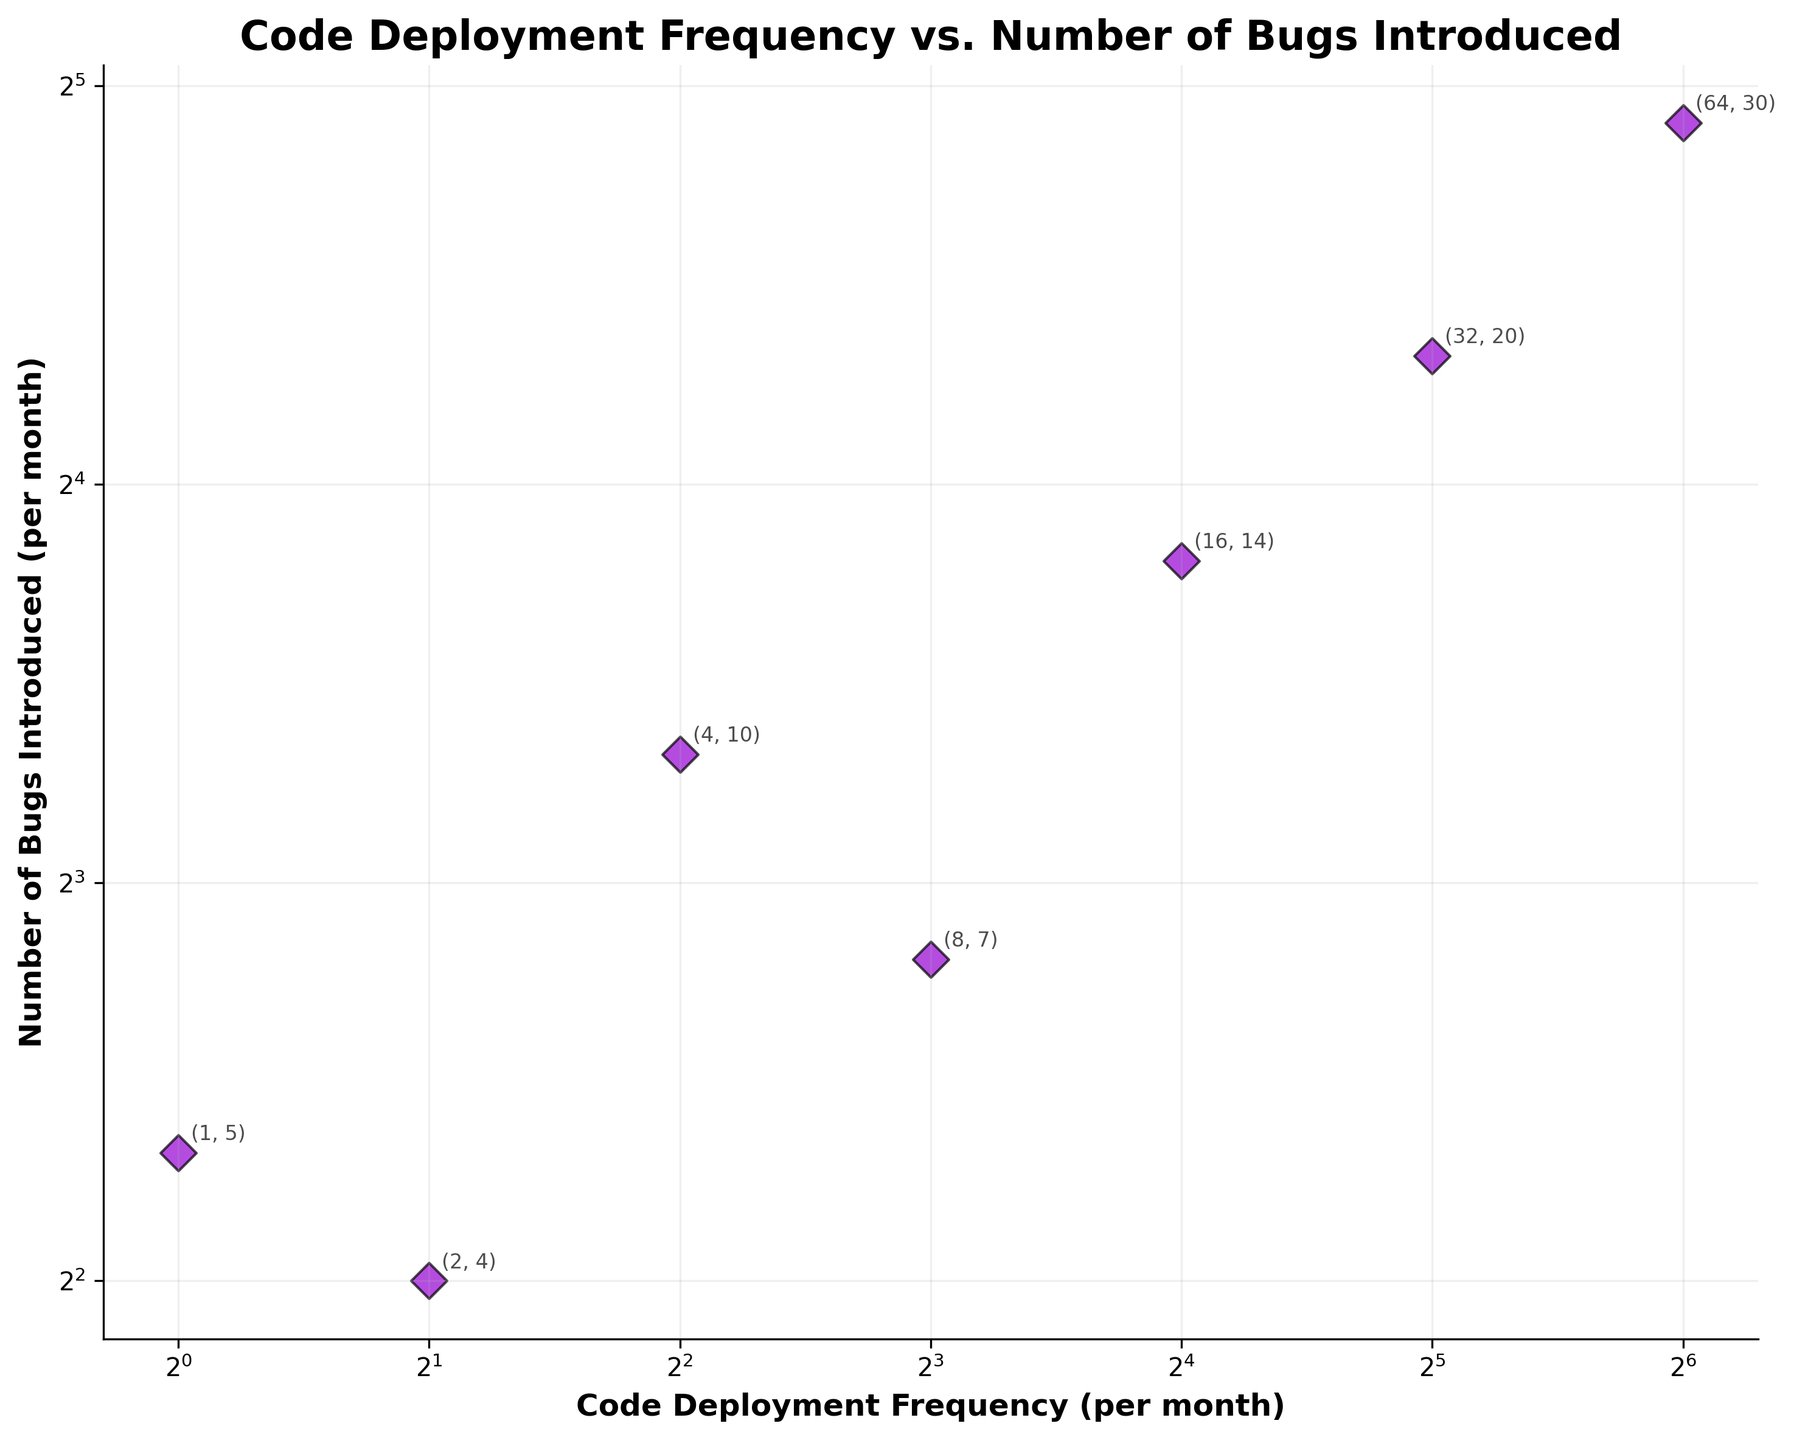What is the title of the scatter plot? The figure's title is displayed at the top and reads "Code Deployment Frequency vs. Number of Bugs Introduced".
Answer: Code Deployment Frequency vs. Number of Bugs Introduced How many data points are in the figure? By visually counting, we can see there are 7 data points plotted on the scatter plot.
Answer: 7 What color are the data points? The data points are depicted in dark violet with black edges.
Answer: Dark violet with black edges Which axis uses a log scale with base 2? Both the x-axis and y-axis use a logarithmic scale with base 2, as observed from the scales marked on them.
Answer: Both axes What is the frequency of code deployment when 20 bugs are introduced? We can trace back from the y-axis value of 20 down to the corresponding x-axis value, which is 32 deployments per month.
Answer: 32 Compared to when there are 5 bugs introduced, how many more deployments are there when 20 bugs are introduced? From the plot, 5 bugs correspond to 1 deployment and 20 bugs correspond to 32 deployments. The difference is 32 - 1 = 31 deployments.
Answer: 31 What is the exact numerical relationship between the deployment frequency and number of bugs when the deployment frequency is 32 per month? By referring to the annotated data point, we see that for 32 deployments, there are 20 bugs introduced.
Answer: 20 Which data point has the highest number of bugs introduced? By locating the highest y-value on the plot, we find that 64 deployments result in 30 bugs, which is the highest on the y-axis.
Answer: 30 If you doubled the deployment frequency from 16 to 32 per month, how does the number of bugs introduced change? When the frequency is doubled from 16 to 32, the number of bugs increases from 14 to 20. Thus, the increase in the number of bugs is 20 - 14 = 6.
Answer: 6 As deployment frequency increases, does the number of bugs increase proportionally, less than proportionally, or more than proportionally? By inspecting the scatter plot, it appears that while the number of bugs generally increases with deployment frequency, it does not perfectly follow a proportional pattern since there’s variation in increments.
Answer: Less than proportionally 